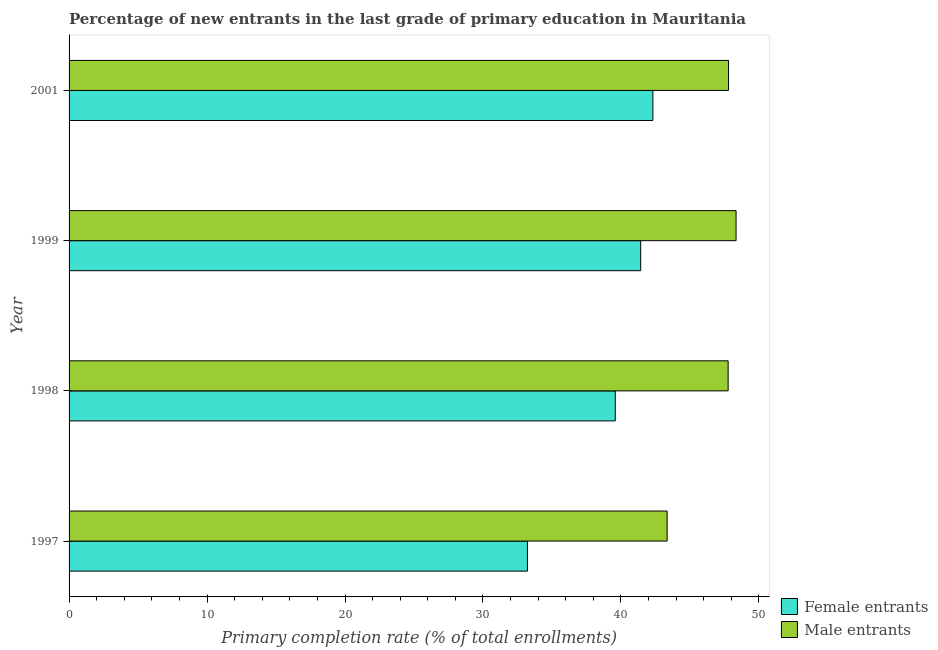Are the number of bars per tick equal to the number of legend labels?
Offer a very short reply. Yes. Are the number of bars on each tick of the Y-axis equal?
Ensure brevity in your answer.  Yes. How many bars are there on the 3rd tick from the top?
Keep it short and to the point. 2. What is the label of the 2nd group of bars from the top?
Your response must be concise. 1999. In how many cases, is the number of bars for a given year not equal to the number of legend labels?
Provide a short and direct response. 0. What is the primary completion rate of male entrants in 1998?
Ensure brevity in your answer.  47.77. Across all years, what is the maximum primary completion rate of male entrants?
Offer a very short reply. 48.35. Across all years, what is the minimum primary completion rate of female entrants?
Keep it short and to the point. 33.23. In which year was the primary completion rate of male entrants minimum?
Give a very brief answer. 1997. What is the total primary completion rate of male entrants in the graph?
Keep it short and to the point. 187.27. What is the difference between the primary completion rate of male entrants in 1998 and that in 1999?
Give a very brief answer. -0.57. What is the difference between the primary completion rate of female entrants in 1997 and the primary completion rate of male entrants in 2001?
Offer a very short reply. -14.58. What is the average primary completion rate of male entrants per year?
Ensure brevity in your answer.  46.82. In the year 2001, what is the difference between the primary completion rate of male entrants and primary completion rate of female entrants?
Your response must be concise. 5.48. Is the primary completion rate of female entrants in 1997 less than that in 2001?
Offer a terse response. Yes. Is the difference between the primary completion rate of female entrants in 1998 and 2001 greater than the difference between the primary completion rate of male entrants in 1998 and 2001?
Provide a short and direct response. No. What is the difference between the highest and the second highest primary completion rate of female entrants?
Provide a succinct answer. 0.89. Is the sum of the primary completion rate of female entrants in 1997 and 2001 greater than the maximum primary completion rate of male entrants across all years?
Make the answer very short. Yes. What does the 1st bar from the top in 2001 represents?
Your response must be concise. Male entrants. What does the 1st bar from the bottom in 1998 represents?
Keep it short and to the point. Female entrants. How many bars are there?
Give a very brief answer. 8. How many years are there in the graph?
Keep it short and to the point. 4. How many legend labels are there?
Provide a succinct answer. 2. How are the legend labels stacked?
Ensure brevity in your answer.  Vertical. What is the title of the graph?
Provide a succinct answer. Percentage of new entrants in the last grade of primary education in Mauritania. What is the label or title of the X-axis?
Keep it short and to the point. Primary completion rate (% of total enrollments). What is the Primary completion rate (% of total enrollments) in Female entrants in 1997?
Ensure brevity in your answer.  33.23. What is the Primary completion rate (% of total enrollments) of Male entrants in 1997?
Provide a short and direct response. 43.35. What is the Primary completion rate (% of total enrollments) in Female entrants in 1998?
Give a very brief answer. 39.59. What is the Primary completion rate (% of total enrollments) of Male entrants in 1998?
Provide a short and direct response. 47.77. What is the Primary completion rate (% of total enrollments) of Female entrants in 1999?
Offer a very short reply. 41.43. What is the Primary completion rate (% of total enrollments) of Male entrants in 1999?
Your answer should be very brief. 48.35. What is the Primary completion rate (% of total enrollments) of Female entrants in 2001?
Your answer should be compact. 42.32. What is the Primary completion rate (% of total enrollments) in Male entrants in 2001?
Keep it short and to the point. 47.8. Across all years, what is the maximum Primary completion rate (% of total enrollments) in Female entrants?
Your answer should be very brief. 42.32. Across all years, what is the maximum Primary completion rate (% of total enrollments) of Male entrants?
Offer a terse response. 48.35. Across all years, what is the minimum Primary completion rate (% of total enrollments) in Female entrants?
Your answer should be very brief. 33.23. Across all years, what is the minimum Primary completion rate (% of total enrollments) in Male entrants?
Your answer should be very brief. 43.35. What is the total Primary completion rate (% of total enrollments) in Female entrants in the graph?
Provide a succinct answer. 156.57. What is the total Primary completion rate (% of total enrollments) of Male entrants in the graph?
Offer a very short reply. 187.27. What is the difference between the Primary completion rate (% of total enrollments) in Female entrants in 1997 and that in 1998?
Ensure brevity in your answer.  -6.37. What is the difference between the Primary completion rate (% of total enrollments) of Male entrants in 1997 and that in 1998?
Give a very brief answer. -4.42. What is the difference between the Primary completion rate (% of total enrollments) in Female entrants in 1997 and that in 1999?
Give a very brief answer. -8.21. What is the difference between the Primary completion rate (% of total enrollments) of Male entrants in 1997 and that in 1999?
Your answer should be very brief. -5. What is the difference between the Primary completion rate (% of total enrollments) in Female entrants in 1997 and that in 2001?
Make the answer very short. -9.09. What is the difference between the Primary completion rate (% of total enrollments) in Male entrants in 1997 and that in 2001?
Give a very brief answer. -4.45. What is the difference between the Primary completion rate (% of total enrollments) in Female entrants in 1998 and that in 1999?
Your answer should be very brief. -1.84. What is the difference between the Primary completion rate (% of total enrollments) of Male entrants in 1998 and that in 1999?
Ensure brevity in your answer.  -0.58. What is the difference between the Primary completion rate (% of total enrollments) in Female entrants in 1998 and that in 2001?
Provide a succinct answer. -2.73. What is the difference between the Primary completion rate (% of total enrollments) in Male entrants in 1998 and that in 2001?
Keep it short and to the point. -0.03. What is the difference between the Primary completion rate (% of total enrollments) of Female entrants in 1999 and that in 2001?
Provide a short and direct response. -0.88. What is the difference between the Primary completion rate (% of total enrollments) of Male entrants in 1999 and that in 2001?
Your answer should be very brief. 0.55. What is the difference between the Primary completion rate (% of total enrollments) of Female entrants in 1997 and the Primary completion rate (% of total enrollments) of Male entrants in 1998?
Ensure brevity in your answer.  -14.55. What is the difference between the Primary completion rate (% of total enrollments) in Female entrants in 1997 and the Primary completion rate (% of total enrollments) in Male entrants in 1999?
Provide a succinct answer. -15.12. What is the difference between the Primary completion rate (% of total enrollments) in Female entrants in 1997 and the Primary completion rate (% of total enrollments) in Male entrants in 2001?
Your answer should be compact. -14.58. What is the difference between the Primary completion rate (% of total enrollments) in Female entrants in 1998 and the Primary completion rate (% of total enrollments) in Male entrants in 1999?
Offer a terse response. -8.76. What is the difference between the Primary completion rate (% of total enrollments) in Female entrants in 1998 and the Primary completion rate (% of total enrollments) in Male entrants in 2001?
Make the answer very short. -8.21. What is the difference between the Primary completion rate (% of total enrollments) of Female entrants in 1999 and the Primary completion rate (% of total enrollments) of Male entrants in 2001?
Your response must be concise. -6.37. What is the average Primary completion rate (% of total enrollments) in Female entrants per year?
Your answer should be very brief. 39.14. What is the average Primary completion rate (% of total enrollments) of Male entrants per year?
Offer a very short reply. 46.82. In the year 1997, what is the difference between the Primary completion rate (% of total enrollments) of Female entrants and Primary completion rate (% of total enrollments) of Male entrants?
Your response must be concise. -10.12. In the year 1998, what is the difference between the Primary completion rate (% of total enrollments) in Female entrants and Primary completion rate (% of total enrollments) in Male entrants?
Offer a very short reply. -8.18. In the year 1999, what is the difference between the Primary completion rate (% of total enrollments) of Female entrants and Primary completion rate (% of total enrollments) of Male entrants?
Provide a succinct answer. -6.91. In the year 2001, what is the difference between the Primary completion rate (% of total enrollments) of Female entrants and Primary completion rate (% of total enrollments) of Male entrants?
Keep it short and to the point. -5.48. What is the ratio of the Primary completion rate (% of total enrollments) in Female entrants in 1997 to that in 1998?
Make the answer very short. 0.84. What is the ratio of the Primary completion rate (% of total enrollments) of Male entrants in 1997 to that in 1998?
Keep it short and to the point. 0.91. What is the ratio of the Primary completion rate (% of total enrollments) in Female entrants in 1997 to that in 1999?
Give a very brief answer. 0.8. What is the ratio of the Primary completion rate (% of total enrollments) of Male entrants in 1997 to that in 1999?
Your response must be concise. 0.9. What is the ratio of the Primary completion rate (% of total enrollments) in Female entrants in 1997 to that in 2001?
Give a very brief answer. 0.79. What is the ratio of the Primary completion rate (% of total enrollments) in Male entrants in 1997 to that in 2001?
Your answer should be compact. 0.91. What is the ratio of the Primary completion rate (% of total enrollments) of Female entrants in 1998 to that in 1999?
Provide a succinct answer. 0.96. What is the ratio of the Primary completion rate (% of total enrollments) of Female entrants in 1998 to that in 2001?
Provide a short and direct response. 0.94. What is the ratio of the Primary completion rate (% of total enrollments) of Female entrants in 1999 to that in 2001?
Your response must be concise. 0.98. What is the ratio of the Primary completion rate (% of total enrollments) of Male entrants in 1999 to that in 2001?
Provide a short and direct response. 1.01. What is the difference between the highest and the second highest Primary completion rate (% of total enrollments) in Female entrants?
Your answer should be compact. 0.88. What is the difference between the highest and the second highest Primary completion rate (% of total enrollments) of Male entrants?
Offer a very short reply. 0.55. What is the difference between the highest and the lowest Primary completion rate (% of total enrollments) of Female entrants?
Make the answer very short. 9.09. What is the difference between the highest and the lowest Primary completion rate (% of total enrollments) of Male entrants?
Provide a succinct answer. 5. 